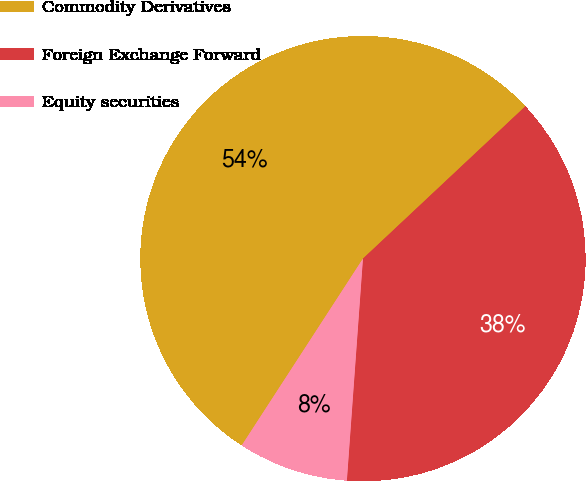Convert chart to OTSL. <chart><loc_0><loc_0><loc_500><loc_500><pie_chart><fcel>Commodity Derivatives<fcel>Foreign Exchange Forward<fcel>Equity securities<nl><fcel>53.85%<fcel>38.14%<fcel>8.01%<nl></chart> 